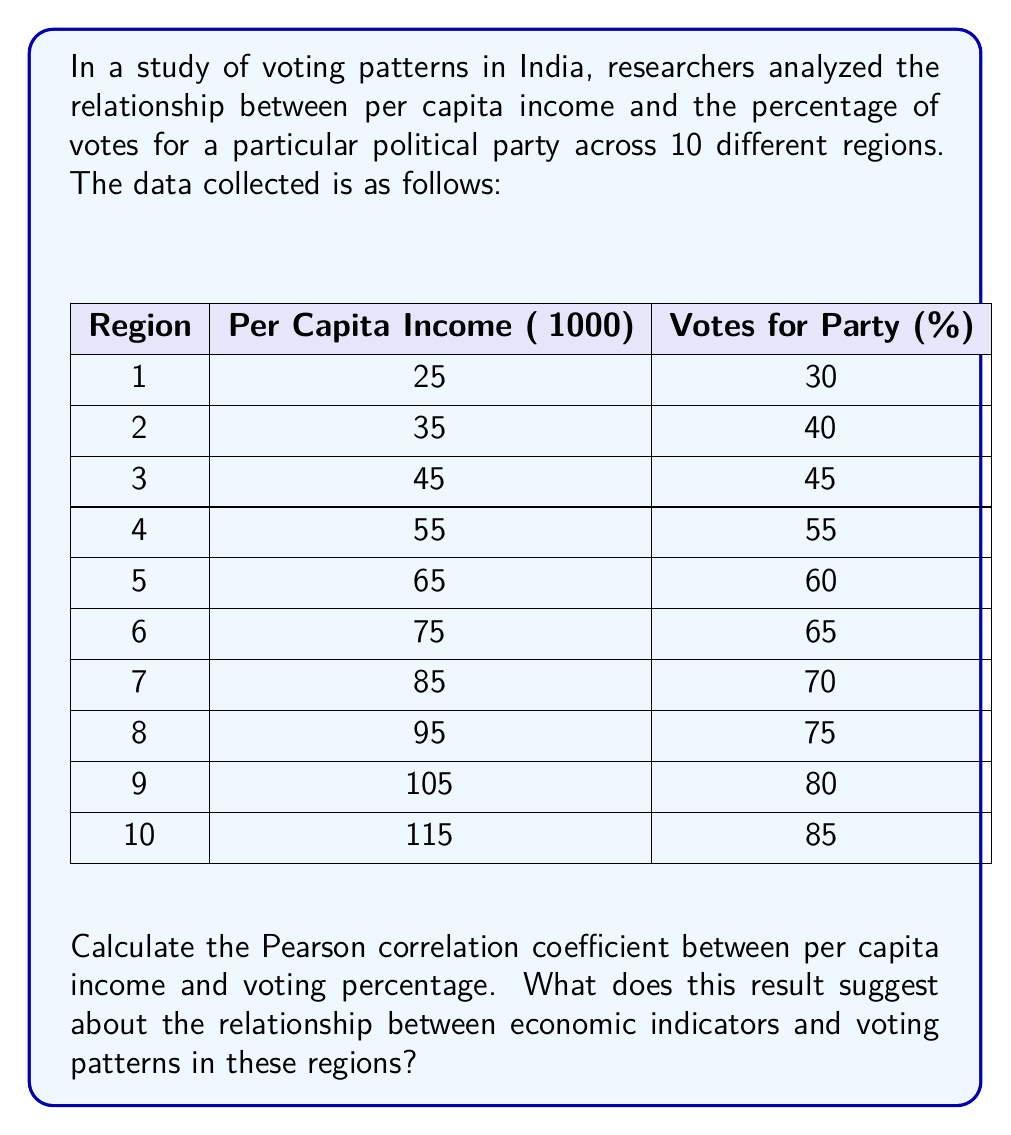Give your solution to this math problem. To calculate the Pearson correlation coefficient, we'll follow these steps:

1) First, we need to calculate the means of both variables:

   $\bar{x} = \frac{\sum x_i}{n} = \frac{700}{10} = 70$ (mean per capita income)
   $\bar{y} = \frac{\sum y_i}{n} = \frac{605}{10} = 60.5$ (mean voting percentage)

2) Next, we calculate the deviations from the mean for each variable:

   $x_i - \bar{x}$ and $y_i - \bar{y}$

3) We then multiply these deviations together for each pair of data points:

   $(x_i - \bar{x})(y_i - \bar{y})$

4) We sum these products:

   $\sum (x_i - \bar{x})(y_i - \bar{y})$

5) We also calculate the sum of squared deviations for each variable:

   $\sum (x_i - \bar{x})^2$ and $\sum (y_i - \bar{y})^2$

6) Finally, we use the formula for the Pearson correlation coefficient:

   $r = \frac{\sum (x_i - \bar{x})(y_i - \bar{y})}{\sqrt{\sum (x_i - \bar{x})^2 \sum (y_i - \bar{y})^2}}$

Calculating these values:

$\sum (x_i - \bar{x})(y_i - \bar{y}) = 4750$
$\sum (x_i - \bar{x})^2 = 8250$
$\sum (y_i - \bar{y})^2 = 2012.5$

Substituting into the formula:

$r = \frac{4750}{\sqrt{8250 * 2012.5}} = \frac{4750}{4075} \approx 0.9963$

This value of r ≈ 0.9963 indicates a very strong positive correlation between per capita income and voting percentage for the party in question. This suggests that in these regions, as per capita income increases, the likelihood of voting for this particular party also increases significantly.
Answer: $r \approx 0.9963$ 